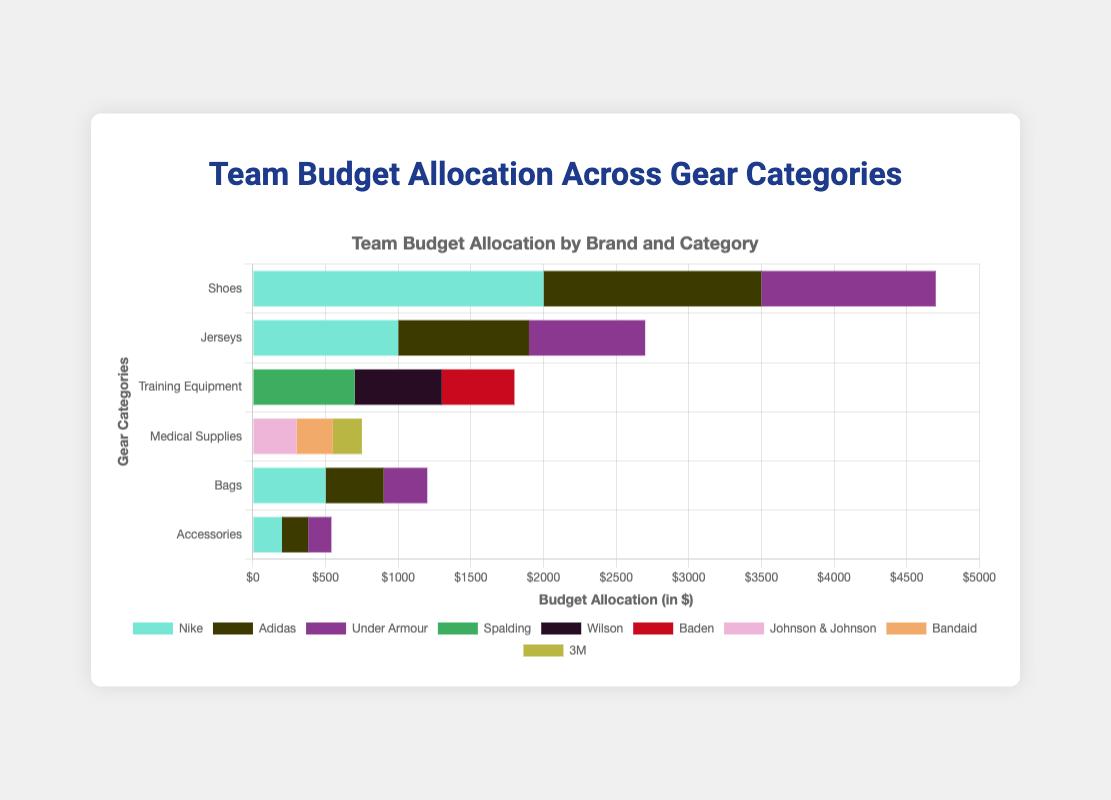Which brand has the highest budget allocation for shoes? To determine the brand with the highest budget allocation for shoes, check the values under the "Shoes" category. Nike is allocated $2000, Adidas $1500, and Under Armour $1200. The highest amount is $2000 which belongs to Nike.
Answer: Nike Which category has the highest total budget allocation? To find the category with the highest total budget allocation, sum the values for each category and compare. For Shoes, the sum is $2000 + $1500 + $1200 = $4700, for Jerseys $1000 + $900 + $800 = $2700, and so on. Shoes have the highest total budget allocation of $4700.
Answer: Shoes Which categories have a budget allocation for Adidas? To identify categories with a budget allocation for Adidas, look for where Adidas is listed. The categories are Shoes ($1500), Jerseys ($900), Bags ($400), and Accessories ($180).
Answer: Shoes, Jerseys, Bags, Accessories What is the overall budget allocation for Nike across all categories? Sum the Nike budget allocations in each category: Shoes $2000, Jerseys $1000, Bags $500, and Accessories $200. The total is $2000 + $1000 + $500 + $200 = $3700.
Answer: $3700 In the Medical Supplies category, which brand has the smallest budget allocation and how much is it? Look at the values under the "Medical Supplies" category. Johnson & Johnson has $300, Bandaid $250, and 3M $200. The smallest allocation is for 3M with $200.
Answer: 3M, $200 How does the budget allocation for bags from Adidas compare to Under Armour? Compare the budget allocations for bags. Adidas is allocated $400, while Under Armour is allocated $300. Adidas has a higher allocation.
Answer: Adidas has a higher allocation What is the combined budget allocation for Spalding and Wilson in the Training Equipment category? Add the budget allocations for Spalding ($700) and Wilson ($600). The combined allocation is $700 + $600 = $1300.
Answer: $1300 How much more is allocated to shoes from Nike than from Under Armour? Subtract the allocation for Under Armour ($1200) from Nike ($2000) to find the difference: $2000 - $1200 = $800.
Answer: $800 Which brand has the second-highest budget allocation for jerseys? In the Jerseys category, Nike has $1000, Adidas $900, and Under Armour $800. The second-highest allocation is $900 for Adidas.
Answer: Adidas How much, altogether, is allocated for accessories from all brands? Add the allocations for Accessories: Nike $200, Adidas $180, and Under Armour $160. The total is $200 + $180 + $160 = $540.
Answer: $540 